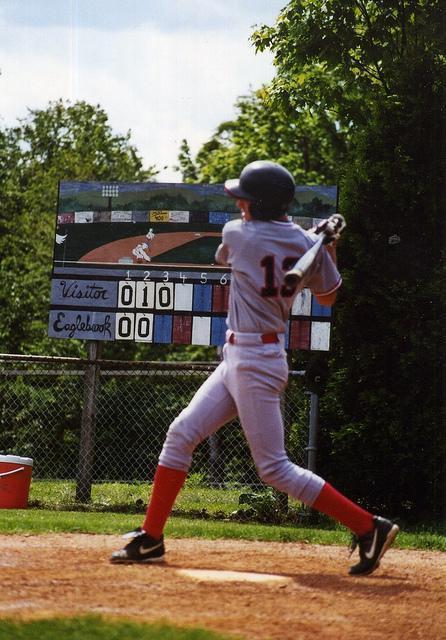Which team is winning?
Select the accurate answer and provide explanation: 'Answer: answer
Rationale: rationale.'
Options: Mets, visitor, eaglebrook, jets. Answer: visitor.
Rationale: Eaglebrook has scored zero points. the other team has one point. 